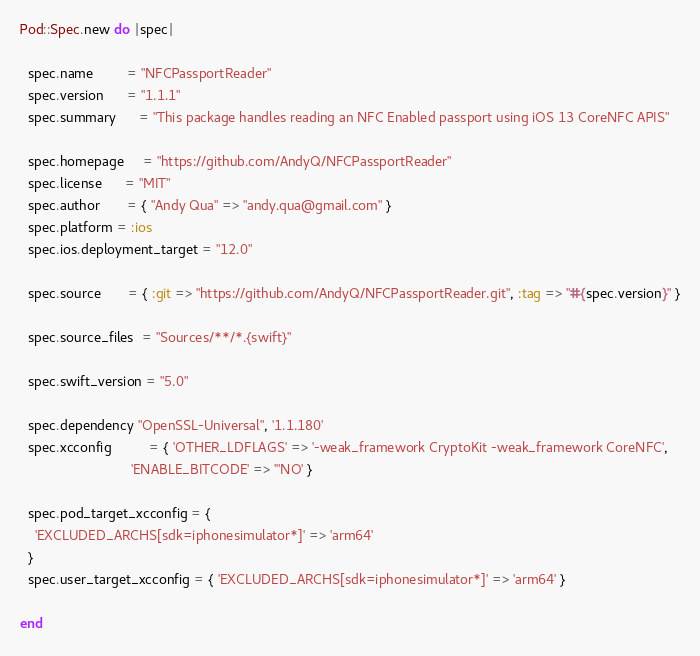<code> <loc_0><loc_0><loc_500><loc_500><_Ruby_>Pod::Spec.new do |spec|

  spec.name         = "NFCPassportReader"
  spec.version      = "1.1.1"
  spec.summary      = "This package handles reading an NFC Enabled passport using iOS 13 CoreNFC APIS"

  spec.homepage     = "https://github.com/AndyQ/NFCPassportReader"
  spec.license      = "MIT"
  spec.author       = { "Andy Qua" => "andy.qua@gmail.com" }
  spec.platform = :ios
  spec.ios.deployment_target = "12.0"

  spec.source       = { :git => "https://github.com/AndyQ/NFCPassportReader.git", :tag => "#{spec.version}" }

  spec.source_files  = "Sources/**/*.{swift}"

  spec.swift_version = "5.0"

  spec.dependency "OpenSSL-Universal", '1.1.180'
  spec.xcconfig          = { 'OTHER_LDFLAGS' => '-weak_framework CryptoKit -weak_framework CoreNFC',
                             'ENABLE_BITCODE' => '"NO' }

  spec.pod_target_xcconfig = {
    'EXCLUDED_ARCHS[sdk=iphonesimulator*]' => 'arm64'
  }
  spec.user_target_xcconfig = { 'EXCLUDED_ARCHS[sdk=iphonesimulator*]' => 'arm64' }

end
</code> 